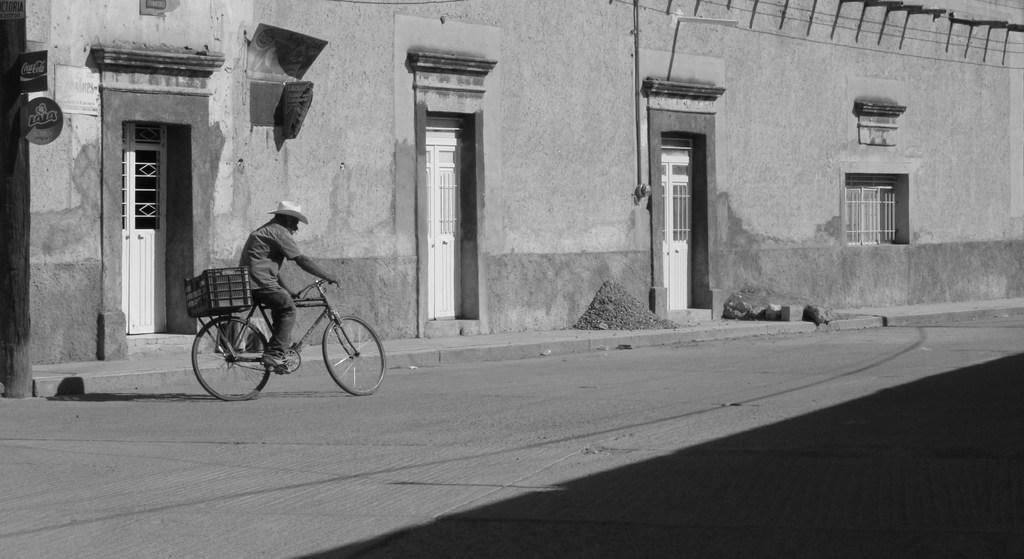Who is the main subject in the image? There is a man in the image. What is the man doing in the image? The man is riding a bicycle. Where is the bicycle located in the image? The bicycle is on the road. What can be seen in the background of the image? There is a building in the background of the image. What features does the building have? The building has doors and windows. Can you tell me how many forks are on the bicycle in the image? There are no forks present on the bicycle in the image. What does the man's grandfather think about his bicycle riding skills? There is no information about the man's grandfather in the image, so it is impossible to answer this question. 